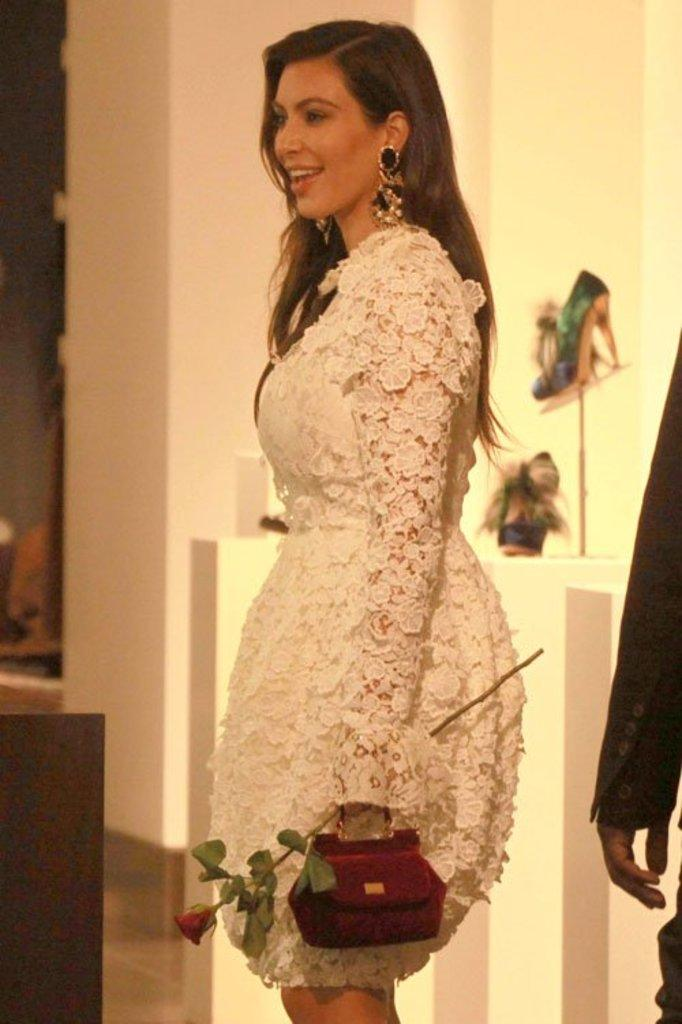Who is present in the image? There is a woman in the image. What is the woman doing in the image? The woman is standing and smiling. What items is the woman holding in the image? The woman is holding a handbag and a rose. Can you describe the background of the image? There is another person in the background of the image, and there is a pair of heels on an object in the background. How many pigs can be seen in the image? There are no pigs present in the image. What is the color of the woman's elbow in the image? The image does not provide information about the color of the woman's elbow. 